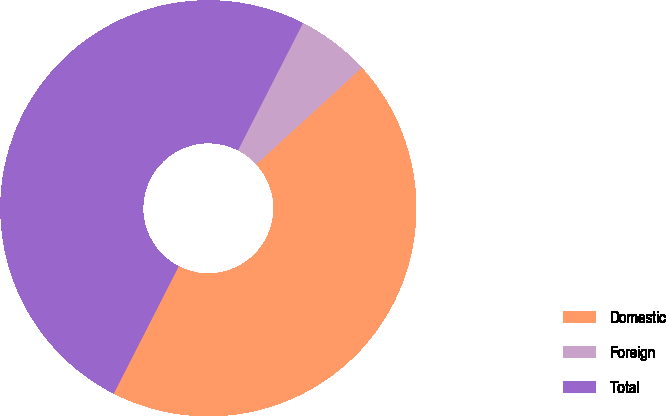Convert chart. <chart><loc_0><loc_0><loc_500><loc_500><pie_chart><fcel>Domestic<fcel>Foreign<fcel>Total<nl><fcel>44.32%<fcel>5.68%<fcel>50.0%<nl></chart> 